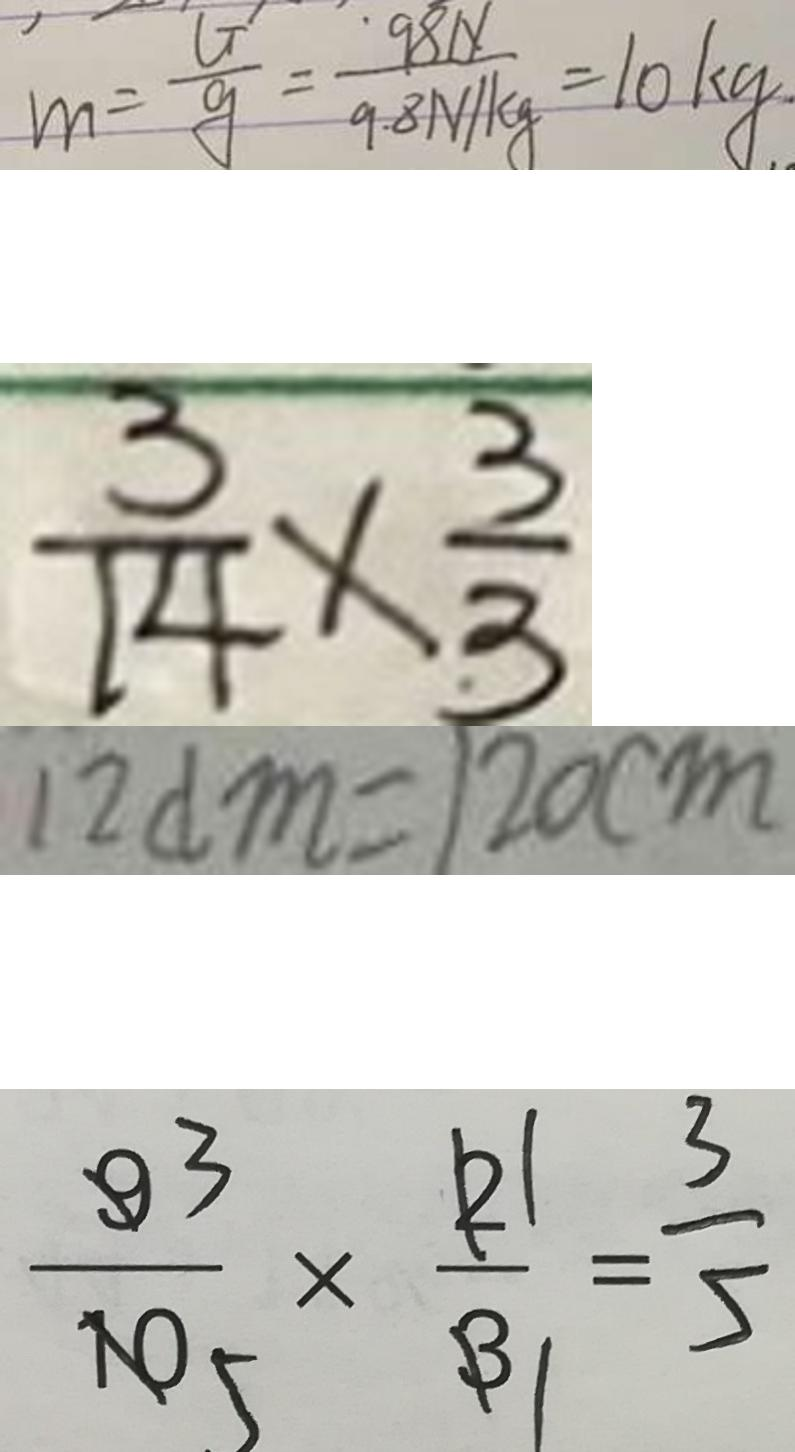Convert formula to latex. <formula><loc_0><loc_0><loc_500><loc_500>m = \frac { G } { 9 } = \frac { 9 8 N } { 9 . 8 N / k g } = 1 0 k g 
 \frac { 3 } { 1 4 } \times \frac { 3 } { 3 } 
 1 2 d m = 1 2 0 c m 
 \frac { 9 } { 1 0 } \times \frac { 2 } { 3 } = \frac { 3 } { 5 }</formula> 